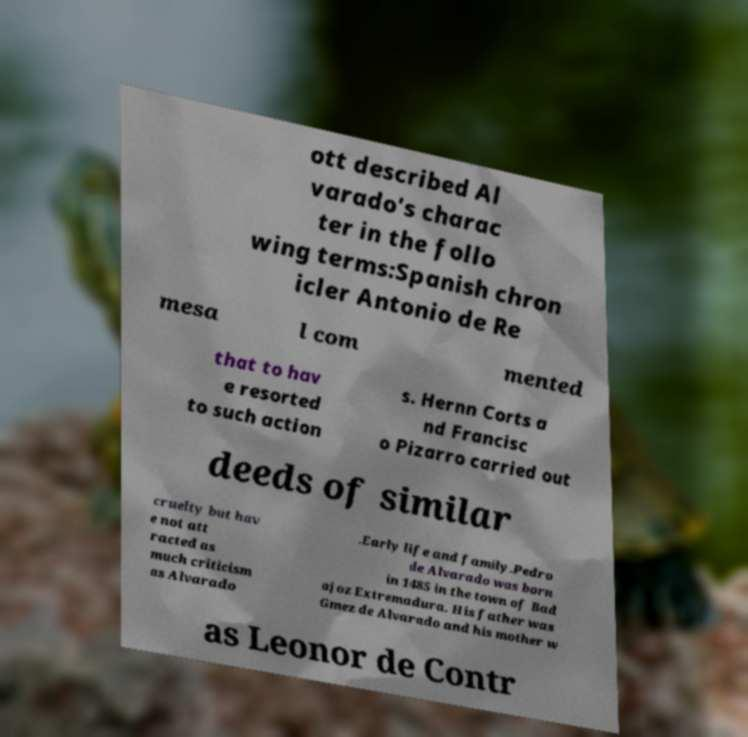Could you extract and type out the text from this image? ott described Al varado's charac ter in the follo wing terms:Spanish chron icler Antonio de Re mesa l com mented that to hav e resorted to such action s. Hernn Corts a nd Francisc o Pizarro carried out deeds of similar cruelty but hav e not att racted as much criticism as Alvarado .Early life and family.Pedro de Alvarado was born in 1485 in the town of Bad ajoz Extremadura. His father was Gmez de Alvarado and his mother w as Leonor de Contr 